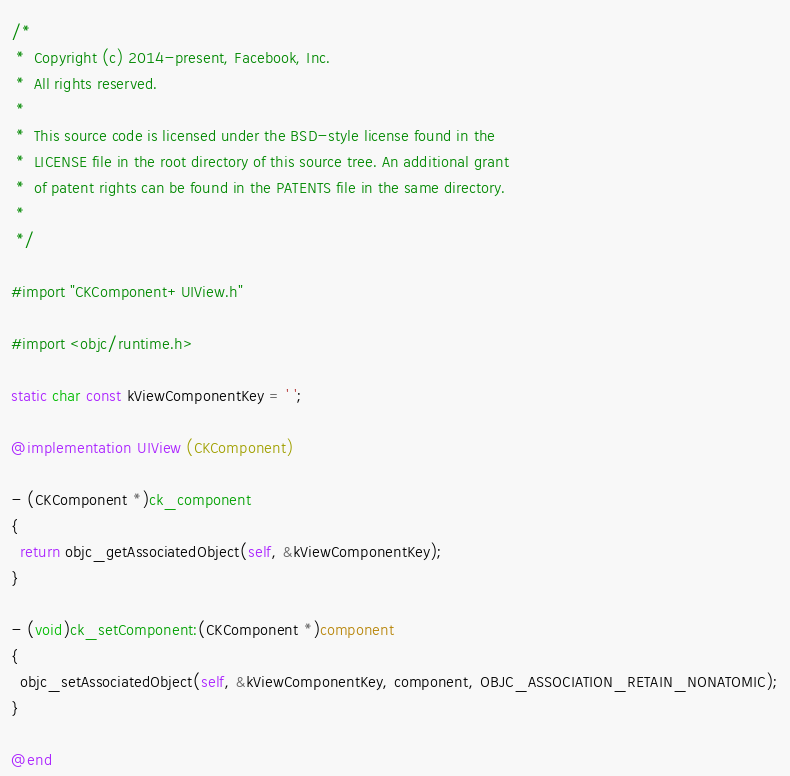Convert code to text. <code><loc_0><loc_0><loc_500><loc_500><_ObjectiveC_>/*
 *  Copyright (c) 2014-present, Facebook, Inc.
 *  All rights reserved.
 *
 *  This source code is licensed under the BSD-style license found in the
 *  LICENSE file in the root directory of this source tree. An additional grant
 *  of patent rights can be found in the PATENTS file in the same directory.
 *
 */

#import "CKComponent+UIView.h"

#import <objc/runtime.h>

static char const kViewComponentKey = ' ';

@implementation UIView (CKComponent)

- (CKComponent *)ck_component
{
  return objc_getAssociatedObject(self, &kViewComponentKey);
}

- (void)ck_setComponent:(CKComponent *)component
{
  objc_setAssociatedObject(self, &kViewComponentKey, component, OBJC_ASSOCIATION_RETAIN_NONATOMIC);
}

@end
</code> 